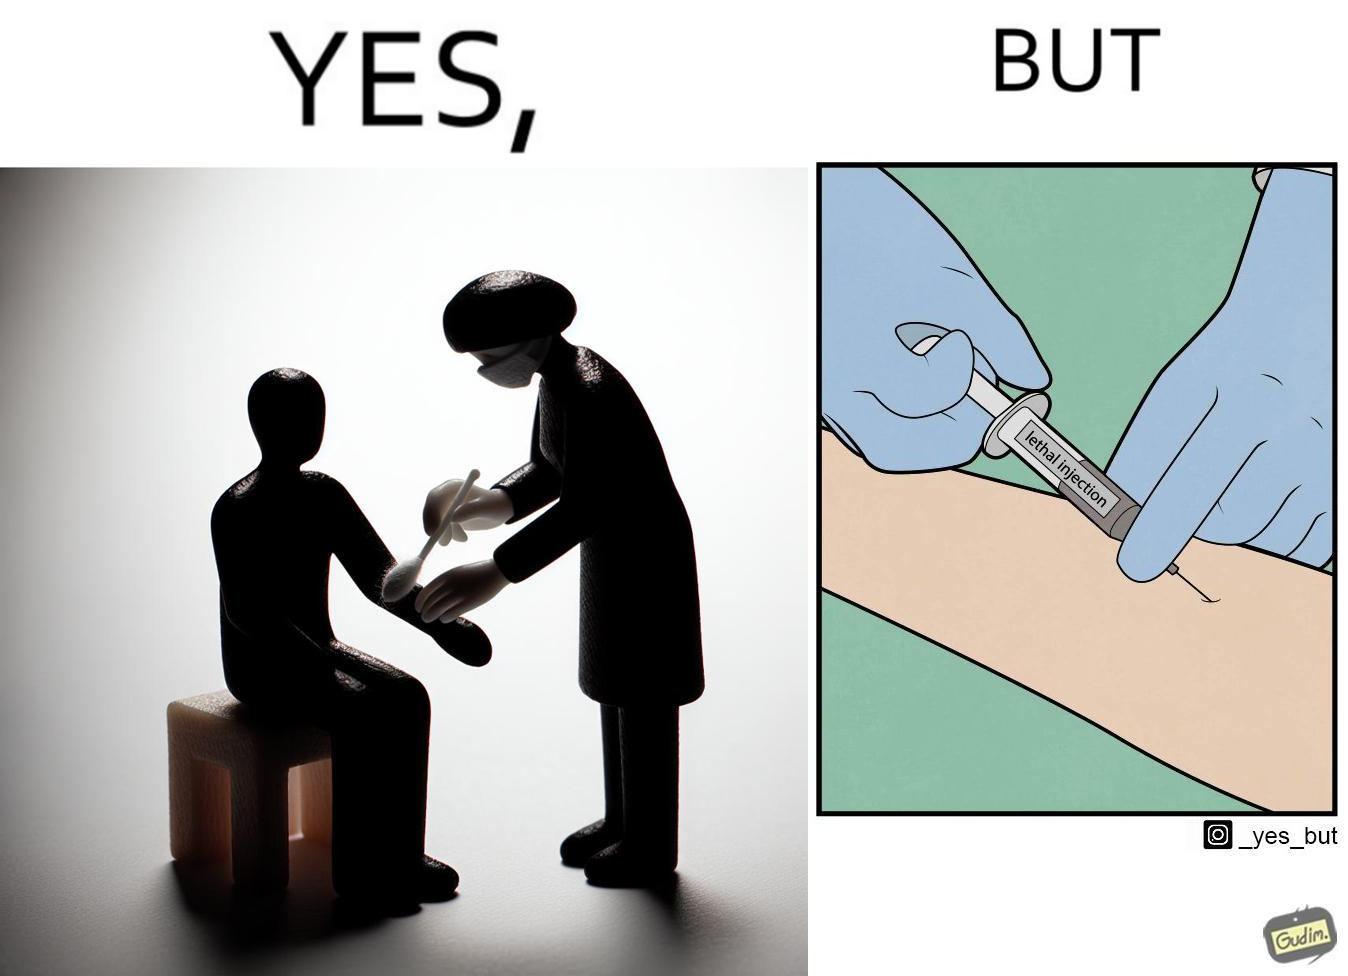Is this image satirical or non-satirical? Yes, this image is satirical. 